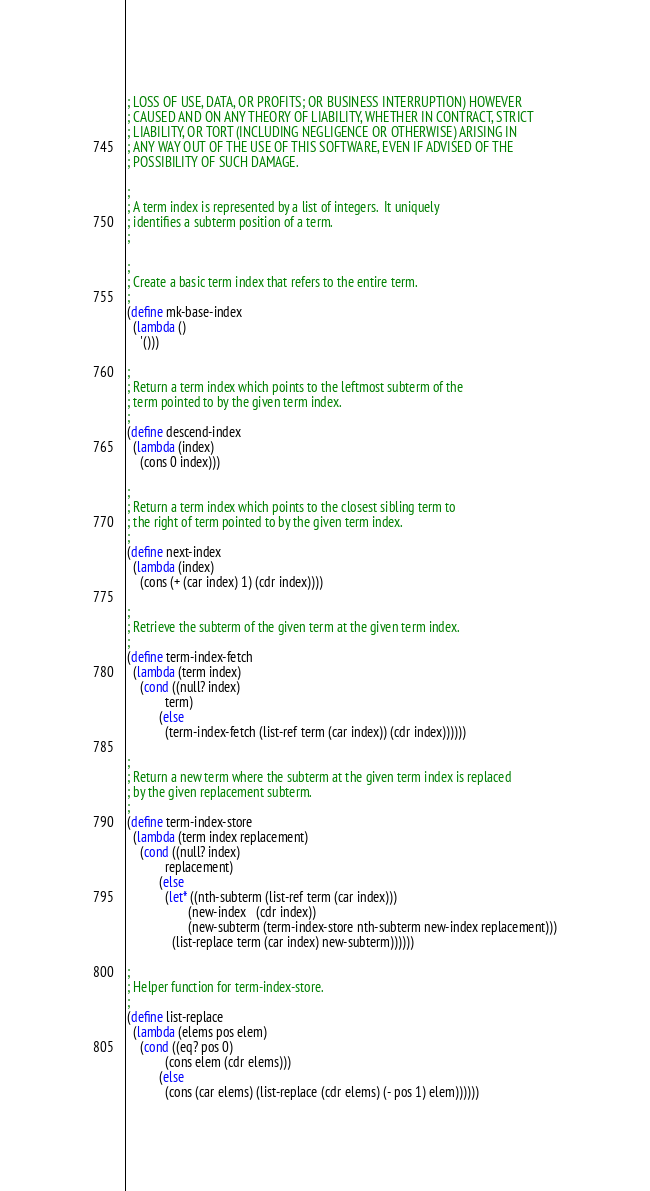<code> <loc_0><loc_0><loc_500><loc_500><_Scheme_>; LOSS OF USE, DATA, OR PROFITS; OR BUSINESS INTERRUPTION) HOWEVER
; CAUSED AND ON ANY THEORY OF LIABILITY, WHETHER IN CONTRACT, STRICT
; LIABILITY, OR TORT (INCLUDING NEGLIGENCE OR OTHERWISE) ARISING IN
; ANY WAY OUT OF THE USE OF THIS SOFTWARE, EVEN IF ADVISED OF THE
; POSSIBILITY OF SUCH DAMAGE.

;
; A term index is represented by a list of integers.  It uniquely
; identifies a subterm position of a term.
;

;
; Create a basic term index that refers to the entire term.
;
(define mk-base-index
  (lambda ()
    '()))

;
; Return a term index which points to the leftmost subterm of the
; term pointed to by the given term index.
;
(define descend-index
  (lambda (index)
    (cons 0 index)))

;
; Return a term index which points to the closest sibling term to
; the right of term pointed to by the given term index.
;
(define next-index
  (lambda (index)
    (cons (+ (car index) 1) (cdr index))))

;
; Retrieve the subterm of the given term at the given term index.
;
(define term-index-fetch
  (lambda (term index)
    (cond ((null? index)
            term)
          (else
            (term-index-fetch (list-ref term (car index)) (cdr index))))))

;
; Return a new term where the subterm at the given term index is replaced
; by the given replacement subterm.
;
(define term-index-store
  (lambda (term index replacement)
    (cond ((null? index)
            replacement)
          (else
            (let* ((nth-subterm (list-ref term (car index)))
                   (new-index   (cdr index))
                   (new-subterm (term-index-store nth-subterm new-index replacement)))
              (list-replace term (car index) new-subterm))))))

;
; Helper function for term-index-store.
;
(define list-replace
  (lambda (elems pos elem)
    (cond ((eq? pos 0)
            (cons elem (cdr elems)))
          (else
            (cons (car elems) (list-replace (cdr elems) (- pos 1) elem))))))
</code> 